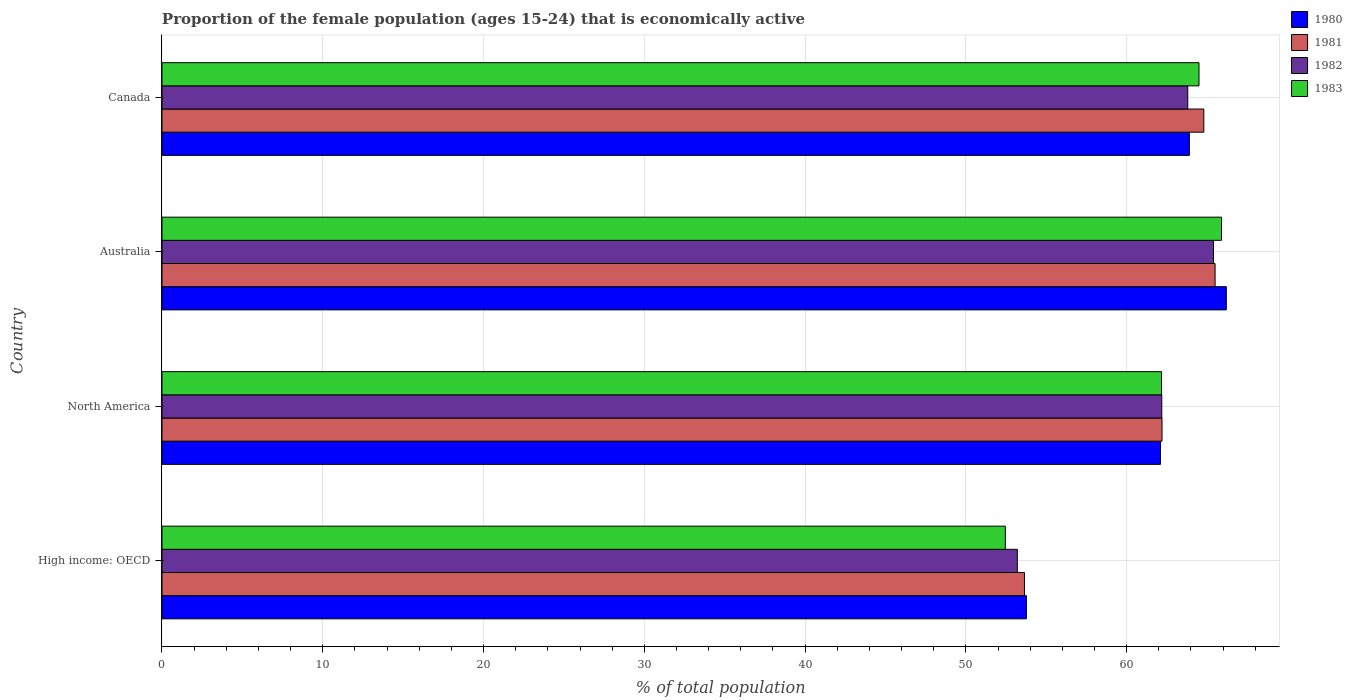How many different coloured bars are there?
Give a very brief answer. 4. Are the number of bars per tick equal to the number of legend labels?
Your response must be concise. Yes. Are the number of bars on each tick of the Y-axis equal?
Offer a terse response. Yes. How many bars are there on the 2nd tick from the top?
Offer a very short reply. 4. What is the label of the 4th group of bars from the top?
Offer a very short reply. High income: OECD. In how many cases, is the number of bars for a given country not equal to the number of legend labels?
Make the answer very short. 0. What is the proportion of the female population that is economically active in 1982 in High income: OECD?
Provide a short and direct response. 53.2. Across all countries, what is the maximum proportion of the female population that is economically active in 1982?
Provide a succinct answer. 65.4. Across all countries, what is the minimum proportion of the female population that is economically active in 1982?
Provide a succinct answer. 53.2. In which country was the proportion of the female population that is economically active in 1983 maximum?
Your response must be concise. Australia. In which country was the proportion of the female population that is economically active in 1981 minimum?
Your answer should be compact. High income: OECD. What is the total proportion of the female population that is economically active in 1983 in the graph?
Make the answer very short. 245.02. What is the difference between the proportion of the female population that is economically active in 1983 in High income: OECD and that in North America?
Provide a succinct answer. -9.71. What is the difference between the proportion of the female population that is economically active in 1980 in Australia and the proportion of the female population that is economically active in 1983 in High income: OECD?
Offer a terse response. 13.75. What is the average proportion of the female population that is economically active in 1982 per country?
Your answer should be very brief. 61.15. What is the difference between the proportion of the female population that is economically active in 1980 and proportion of the female population that is economically active in 1982 in North America?
Make the answer very short. -0.08. In how many countries, is the proportion of the female population that is economically active in 1980 greater than 14 %?
Keep it short and to the point. 4. What is the ratio of the proportion of the female population that is economically active in 1981 in High income: OECD to that in North America?
Provide a succinct answer. 0.86. Is the proportion of the female population that is economically active in 1980 in Canada less than that in High income: OECD?
Ensure brevity in your answer.  No. What is the difference between the highest and the second highest proportion of the female population that is economically active in 1983?
Your answer should be very brief. 1.4. What is the difference between the highest and the lowest proportion of the female population that is economically active in 1983?
Make the answer very short. 13.45. What does the 2nd bar from the top in Australia represents?
Provide a succinct answer. 1982. Is it the case that in every country, the sum of the proportion of the female population that is economically active in 1980 and proportion of the female population that is economically active in 1981 is greater than the proportion of the female population that is economically active in 1982?
Offer a very short reply. Yes. How many bars are there?
Make the answer very short. 16. How many countries are there in the graph?
Ensure brevity in your answer.  4. Are the values on the major ticks of X-axis written in scientific E-notation?
Your answer should be very brief. No. Does the graph contain any zero values?
Keep it short and to the point. No. Where does the legend appear in the graph?
Make the answer very short. Top right. What is the title of the graph?
Give a very brief answer. Proportion of the female population (ages 15-24) that is economically active. Does "1999" appear as one of the legend labels in the graph?
Keep it short and to the point. No. What is the label or title of the X-axis?
Offer a very short reply. % of total population. What is the label or title of the Y-axis?
Offer a very short reply. Country. What is the % of total population in 1980 in High income: OECD?
Your response must be concise. 53.76. What is the % of total population in 1981 in High income: OECD?
Offer a very short reply. 53.64. What is the % of total population of 1982 in High income: OECD?
Offer a very short reply. 53.2. What is the % of total population of 1983 in High income: OECD?
Offer a very short reply. 52.45. What is the % of total population in 1980 in North America?
Offer a very short reply. 62.11. What is the % of total population of 1981 in North America?
Make the answer very short. 62.2. What is the % of total population of 1982 in North America?
Offer a very short reply. 62.19. What is the % of total population in 1983 in North America?
Provide a short and direct response. 62.17. What is the % of total population of 1980 in Australia?
Offer a very short reply. 66.2. What is the % of total population of 1981 in Australia?
Ensure brevity in your answer.  65.5. What is the % of total population of 1982 in Australia?
Offer a terse response. 65.4. What is the % of total population in 1983 in Australia?
Your answer should be compact. 65.9. What is the % of total population of 1980 in Canada?
Keep it short and to the point. 63.9. What is the % of total population in 1981 in Canada?
Your answer should be very brief. 64.8. What is the % of total population in 1982 in Canada?
Make the answer very short. 63.8. What is the % of total population of 1983 in Canada?
Keep it short and to the point. 64.5. Across all countries, what is the maximum % of total population of 1980?
Your response must be concise. 66.2. Across all countries, what is the maximum % of total population of 1981?
Your response must be concise. 65.5. Across all countries, what is the maximum % of total population in 1982?
Give a very brief answer. 65.4. Across all countries, what is the maximum % of total population in 1983?
Your answer should be very brief. 65.9. Across all countries, what is the minimum % of total population in 1980?
Ensure brevity in your answer.  53.76. Across all countries, what is the minimum % of total population of 1981?
Offer a terse response. 53.64. Across all countries, what is the minimum % of total population in 1982?
Keep it short and to the point. 53.2. Across all countries, what is the minimum % of total population of 1983?
Your answer should be compact. 52.45. What is the total % of total population in 1980 in the graph?
Provide a short and direct response. 245.97. What is the total % of total population of 1981 in the graph?
Give a very brief answer. 246.14. What is the total % of total population of 1982 in the graph?
Offer a terse response. 244.58. What is the total % of total population in 1983 in the graph?
Provide a succinct answer. 245.02. What is the difference between the % of total population of 1980 in High income: OECD and that in North America?
Ensure brevity in your answer.  -8.34. What is the difference between the % of total population of 1981 in High income: OECD and that in North America?
Your answer should be very brief. -8.56. What is the difference between the % of total population of 1982 in High income: OECD and that in North America?
Give a very brief answer. -8.99. What is the difference between the % of total population of 1983 in High income: OECD and that in North America?
Provide a succinct answer. -9.71. What is the difference between the % of total population in 1980 in High income: OECD and that in Australia?
Offer a very short reply. -12.44. What is the difference between the % of total population of 1981 in High income: OECD and that in Australia?
Ensure brevity in your answer.  -11.86. What is the difference between the % of total population of 1982 in High income: OECD and that in Australia?
Ensure brevity in your answer.  -12.2. What is the difference between the % of total population of 1983 in High income: OECD and that in Australia?
Provide a short and direct response. -13.45. What is the difference between the % of total population in 1980 in High income: OECD and that in Canada?
Provide a succinct answer. -10.14. What is the difference between the % of total population in 1981 in High income: OECD and that in Canada?
Make the answer very short. -11.16. What is the difference between the % of total population in 1982 in High income: OECD and that in Canada?
Give a very brief answer. -10.6. What is the difference between the % of total population in 1983 in High income: OECD and that in Canada?
Provide a succinct answer. -12.05. What is the difference between the % of total population in 1980 in North America and that in Australia?
Ensure brevity in your answer.  -4.09. What is the difference between the % of total population in 1981 in North America and that in Australia?
Your answer should be very brief. -3.3. What is the difference between the % of total population of 1982 in North America and that in Australia?
Your answer should be compact. -3.21. What is the difference between the % of total population in 1983 in North America and that in Australia?
Offer a very short reply. -3.73. What is the difference between the % of total population in 1980 in North America and that in Canada?
Ensure brevity in your answer.  -1.79. What is the difference between the % of total population in 1981 in North America and that in Canada?
Offer a terse response. -2.6. What is the difference between the % of total population in 1982 in North America and that in Canada?
Keep it short and to the point. -1.61. What is the difference between the % of total population in 1983 in North America and that in Canada?
Keep it short and to the point. -2.33. What is the difference between the % of total population in 1982 in Australia and that in Canada?
Your answer should be compact. 1.6. What is the difference between the % of total population of 1983 in Australia and that in Canada?
Your answer should be very brief. 1.4. What is the difference between the % of total population in 1980 in High income: OECD and the % of total population in 1981 in North America?
Make the answer very short. -8.44. What is the difference between the % of total population in 1980 in High income: OECD and the % of total population in 1982 in North America?
Give a very brief answer. -8.42. What is the difference between the % of total population in 1980 in High income: OECD and the % of total population in 1983 in North America?
Give a very brief answer. -8.4. What is the difference between the % of total population of 1981 in High income: OECD and the % of total population of 1982 in North America?
Your response must be concise. -8.54. What is the difference between the % of total population of 1981 in High income: OECD and the % of total population of 1983 in North America?
Provide a short and direct response. -8.52. What is the difference between the % of total population in 1982 in High income: OECD and the % of total population in 1983 in North America?
Offer a very short reply. -8.97. What is the difference between the % of total population in 1980 in High income: OECD and the % of total population in 1981 in Australia?
Your answer should be compact. -11.74. What is the difference between the % of total population in 1980 in High income: OECD and the % of total population in 1982 in Australia?
Your answer should be compact. -11.64. What is the difference between the % of total population in 1980 in High income: OECD and the % of total population in 1983 in Australia?
Keep it short and to the point. -12.14. What is the difference between the % of total population in 1981 in High income: OECD and the % of total population in 1982 in Australia?
Keep it short and to the point. -11.76. What is the difference between the % of total population of 1981 in High income: OECD and the % of total population of 1983 in Australia?
Provide a succinct answer. -12.26. What is the difference between the % of total population of 1982 in High income: OECD and the % of total population of 1983 in Australia?
Give a very brief answer. -12.7. What is the difference between the % of total population in 1980 in High income: OECD and the % of total population in 1981 in Canada?
Your response must be concise. -11.04. What is the difference between the % of total population of 1980 in High income: OECD and the % of total population of 1982 in Canada?
Offer a terse response. -10.04. What is the difference between the % of total population of 1980 in High income: OECD and the % of total population of 1983 in Canada?
Provide a short and direct response. -10.74. What is the difference between the % of total population in 1981 in High income: OECD and the % of total population in 1982 in Canada?
Your answer should be very brief. -10.16. What is the difference between the % of total population in 1981 in High income: OECD and the % of total population in 1983 in Canada?
Offer a terse response. -10.86. What is the difference between the % of total population of 1982 in High income: OECD and the % of total population of 1983 in Canada?
Provide a short and direct response. -11.3. What is the difference between the % of total population in 1980 in North America and the % of total population in 1981 in Australia?
Offer a very short reply. -3.39. What is the difference between the % of total population in 1980 in North America and the % of total population in 1982 in Australia?
Offer a terse response. -3.29. What is the difference between the % of total population of 1980 in North America and the % of total population of 1983 in Australia?
Make the answer very short. -3.79. What is the difference between the % of total population in 1981 in North America and the % of total population in 1982 in Australia?
Keep it short and to the point. -3.2. What is the difference between the % of total population of 1981 in North America and the % of total population of 1983 in Australia?
Your answer should be very brief. -3.7. What is the difference between the % of total population in 1982 in North America and the % of total population in 1983 in Australia?
Ensure brevity in your answer.  -3.71. What is the difference between the % of total population of 1980 in North America and the % of total population of 1981 in Canada?
Provide a short and direct response. -2.69. What is the difference between the % of total population of 1980 in North America and the % of total population of 1982 in Canada?
Offer a terse response. -1.69. What is the difference between the % of total population in 1980 in North America and the % of total population in 1983 in Canada?
Make the answer very short. -2.39. What is the difference between the % of total population in 1981 in North America and the % of total population in 1982 in Canada?
Your answer should be compact. -1.6. What is the difference between the % of total population of 1981 in North America and the % of total population of 1983 in Canada?
Ensure brevity in your answer.  -2.3. What is the difference between the % of total population of 1982 in North America and the % of total population of 1983 in Canada?
Offer a very short reply. -2.31. What is the difference between the % of total population of 1980 in Australia and the % of total population of 1983 in Canada?
Ensure brevity in your answer.  1.7. What is the difference between the % of total population in 1981 in Australia and the % of total population in 1982 in Canada?
Offer a terse response. 1.7. What is the average % of total population of 1980 per country?
Make the answer very short. 61.49. What is the average % of total population in 1981 per country?
Make the answer very short. 61.54. What is the average % of total population of 1982 per country?
Provide a succinct answer. 61.15. What is the average % of total population in 1983 per country?
Ensure brevity in your answer.  61.26. What is the difference between the % of total population in 1980 and % of total population in 1981 in High income: OECD?
Give a very brief answer. 0.12. What is the difference between the % of total population of 1980 and % of total population of 1982 in High income: OECD?
Provide a short and direct response. 0.57. What is the difference between the % of total population in 1980 and % of total population in 1983 in High income: OECD?
Your response must be concise. 1.31. What is the difference between the % of total population in 1981 and % of total population in 1982 in High income: OECD?
Your response must be concise. 0.44. What is the difference between the % of total population of 1981 and % of total population of 1983 in High income: OECD?
Your answer should be compact. 1.19. What is the difference between the % of total population in 1982 and % of total population in 1983 in High income: OECD?
Your answer should be compact. 0.75. What is the difference between the % of total population of 1980 and % of total population of 1981 in North America?
Your response must be concise. -0.09. What is the difference between the % of total population in 1980 and % of total population in 1982 in North America?
Provide a short and direct response. -0.08. What is the difference between the % of total population of 1980 and % of total population of 1983 in North America?
Offer a very short reply. -0.06. What is the difference between the % of total population in 1981 and % of total population in 1982 in North America?
Offer a very short reply. 0.01. What is the difference between the % of total population in 1981 and % of total population in 1983 in North America?
Keep it short and to the point. 0.03. What is the difference between the % of total population in 1982 and % of total population in 1983 in North America?
Give a very brief answer. 0.02. What is the difference between the % of total population of 1980 and % of total population of 1981 in Australia?
Offer a very short reply. 0.7. What is the difference between the % of total population of 1980 and % of total population of 1983 in Australia?
Give a very brief answer. 0.3. What is the difference between the % of total population of 1982 and % of total population of 1983 in Australia?
Provide a short and direct response. -0.5. What is the difference between the % of total population of 1980 and % of total population of 1983 in Canada?
Make the answer very short. -0.6. What is the ratio of the % of total population of 1980 in High income: OECD to that in North America?
Make the answer very short. 0.87. What is the ratio of the % of total population of 1981 in High income: OECD to that in North America?
Your response must be concise. 0.86. What is the ratio of the % of total population in 1982 in High income: OECD to that in North America?
Your answer should be compact. 0.86. What is the ratio of the % of total population of 1983 in High income: OECD to that in North America?
Provide a succinct answer. 0.84. What is the ratio of the % of total population of 1980 in High income: OECD to that in Australia?
Make the answer very short. 0.81. What is the ratio of the % of total population in 1981 in High income: OECD to that in Australia?
Your response must be concise. 0.82. What is the ratio of the % of total population in 1982 in High income: OECD to that in Australia?
Offer a very short reply. 0.81. What is the ratio of the % of total population of 1983 in High income: OECD to that in Australia?
Ensure brevity in your answer.  0.8. What is the ratio of the % of total population in 1980 in High income: OECD to that in Canada?
Provide a succinct answer. 0.84. What is the ratio of the % of total population in 1981 in High income: OECD to that in Canada?
Provide a succinct answer. 0.83. What is the ratio of the % of total population in 1982 in High income: OECD to that in Canada?
Provide a succinct answer. 0.83. What is the ratio of the % of total population of 1983 in High income: OECD to that in Canada?
Make the answer very short. 0.81. What is the ratio of the % of total population in 1980 in North America to that in Australia?
Provide a succinct answer. 0.94. What is the ratio of the % of total population in 1981 in North America to that in Australia?
Provide a succinct answer. 0.95. What is the ratio of the % of total population in 1982 in North America to that in Australia?
Offer a terse response. 0.95. What is the ratio of the % of total population in 1983 in North America to that in Australia?
Your answer should be compact. 0.94. What is the ratio of the % of total population in 1980 in North America to that in Canada?
Keep it short and to the point. 0.97. What is the ratio of the % of total population of 1981 in North America to that in Canada?
Your answer should be compact. 0.96. What is the ratio of the % of total population of 1982 in North America to that in Canada?
Keep it short and to the point. 0.97. What is the ratio of the % of total population of 1983 in North America to that in Canada?
Your answer should be very brief. 0.96. What is the ratio of the % of total population in 1980 in Australia to that in Canada?
Ensure brevity in your answer.  1.04. What is the ratio of the % of total population of 1981 in Australia to that in Canada?
Provide a short and direct response. 1.01. What is the ratio of the % of total population of 1982 in Australia to that in Canada?
Keep it short and to the point. 1.03. What is the ratio of the % of total population of 1983 in Australia to that in Canada?
Provide a short and direct response. 1.02. What is the difference between the highest and the second highest % of total population of 1980?
Your answer should be compact. 2.3. What is the difference between the highest and the second highest % of total population in 1981?
Give a very brief answer. 0.7. What is the difference between the highest and the second highest % of total population in 1982?
Make the answer very short. 1.6. What is the difference between the highest and the lowest % of total population in 1980?
Your answer should be compact. 12.44. What is the difference between the highest and the lowest % of total population of 1981?
Your answer should be compact. 11.86. What is the difference between the highest and the lowest % of total population of 1982?
Make the answer very short. 12.2. What is the difference between the highest and the lowest % of total population of 1983?
Offer a terse response. 13.45. 